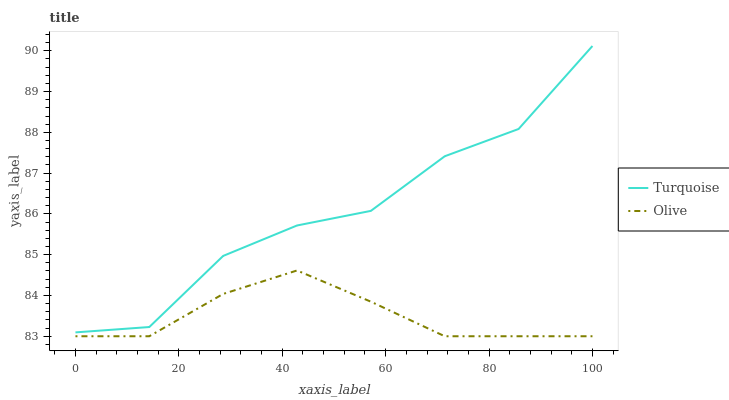Does Turquoise have the minimum area under the curve?
Answer yes or no. No. Is Turquoise the smoothest?
Answer yes or no. No. Does Turquoise have the lowest value?
Answer yes or no. No. Is Olive less than Turquoise?
Answer yes or no. Yes. Is Turquoise greater than Olive?
Answer yes or no. Yes. Does Olive intersect Turquoise?
Answer yes or no. No. 